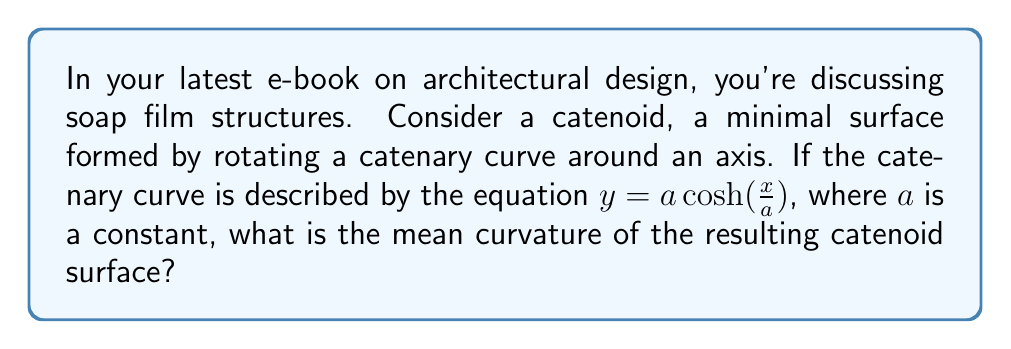Help me with this question. Let's approach this step-by-step:

1) The catenoid is a surface of revolution obtained by rotating the catenary curve $y = a \cosh(\frac{x}{a})$ around the x-axis.

2) In general, for a surface of revolution described by $(x, r(x)\cos\theta, r(x)\sin\theta)$, the mean curvature $H$ is given by:

   $$H = \frac{r''(x)}{2(1+r'(x)^2)^{3/2}} - \frac{1}{2r(x)(1+r'(x)^2)^{1/2}}$$

3) In our case, $r(x) = a \cosh(\frac{x}{a})$. Let's calculate $r'(x)$ and $r''(x)$:

   $r'(x) = \sinh(\frac{x}{a})$
   $r''(x) = \frac{1}{a}\cosh(\frac{x}{a})$

4) Substituting these into the mean curvature formula:

   $$H = \frac{\frac{1}{a}\cosh(\frac{x}{a})}{2(1+\sinh^2(\frac{x}{a}))^{3/2}} - \frac{1}{2a\cosh(\frac{x}{a})(1+\sinh^2(\frac{x}{a}))^{1/2}}$$

5) Recall the identity $\cosh^2(x) - \sinh^2(x) = 1$, or equivalently, $1 + \sinh^2(x) = \cosh^2(x)$

6) Applying this identity:

   $$H = \frac{\frac{1}{a}\cosh(\frac{x}{a})}{2\cosh^3(\frac{x}{a})} - \frac{1}{2a\cosh(\frac{x}{a})\cosh(\frac{x}{a})}$$

7) Simplifying:

   $$H = \frac{1}{2a\cosh^2(\frac{x}{a})} - \frac{1}{2a\cosh^2(\frac{x}{a})} = 0$$

Therefore, the mean curvature of the catenoid is zero everywhere, which is a defining property of minimal surfaces.
Answer: $H = 0$ 